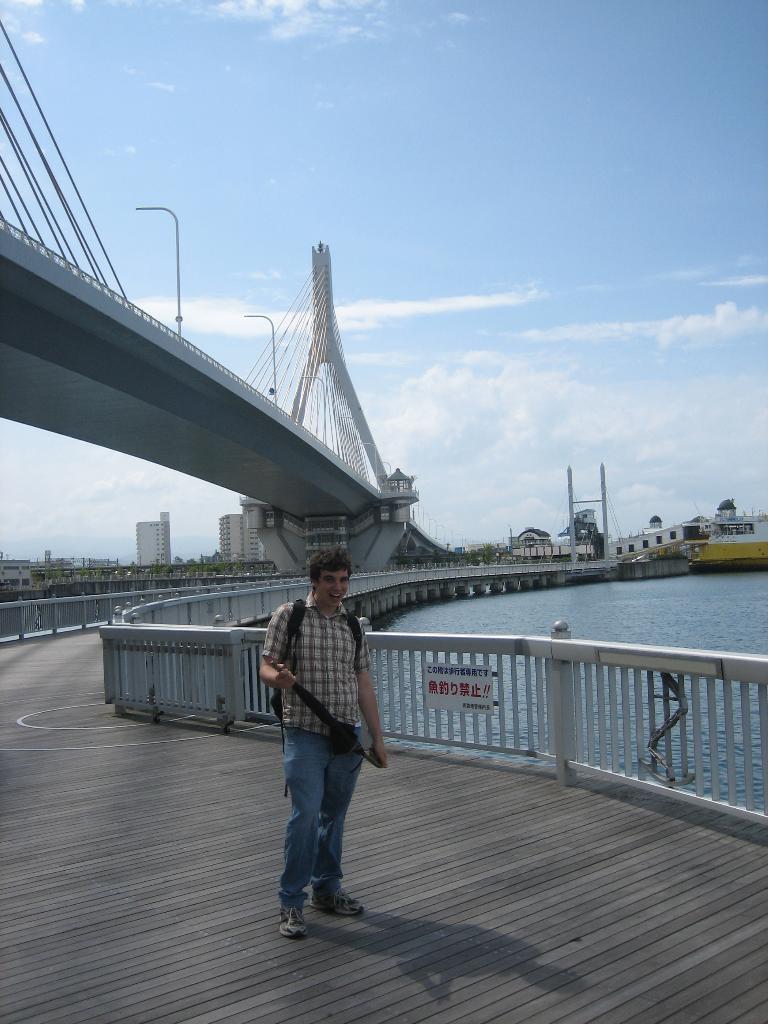Can you describe this image briefly? In the foreground of this image, there is a man standing on the path. In the background, there is a railing of a bridge, a flyover, water, buildings, sky and the cloud. 